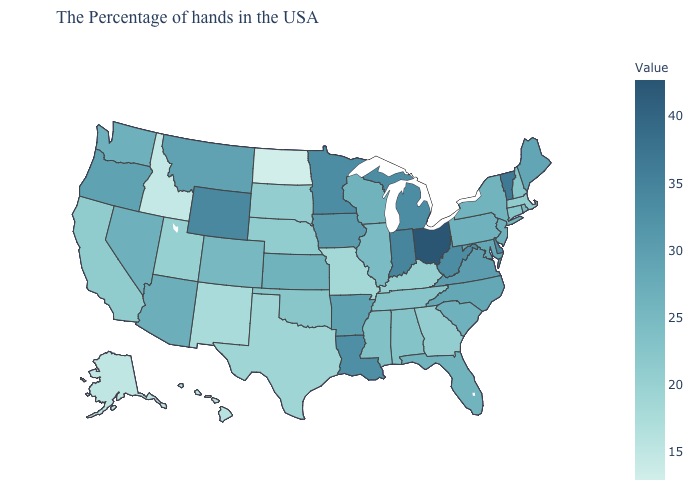Does the map have missing data?
Keep it brief. No. Which states have the lowest value in the USA?
Be succinct. North Dakota. Among the states that border Pennsylvania , does New York have the highest value?
Short answer required. No. Does Delaware have the highest value in the South?
Answer briefly. Yes. Is the legend a continuous bar?
Write a very short answer. Yes. Which states hav the highest value in the South?
Give a very brief answer. Delaware. Does Florida have the lowest value in the USA?
Give a very brief answer. No. Does Texas have the lowest value in the South?
Quick response, please. Yes. Among the states that border North Carolina , does Tennessee have the lowest value?
Concise answer only. No. 